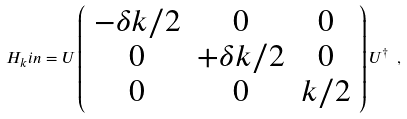<formula> <loc_0><loc_0><loc_500><loc_500>H _ { k } i n = U \left ( \begin{array} { c c c } - \delta k / 2 & 0 & 0 \\ 0 & + \delta k / 2 & 0 \\ 0 & 0 & k / 2 \end{array} \right ) U ^ { \dag } \ ,</formula> 